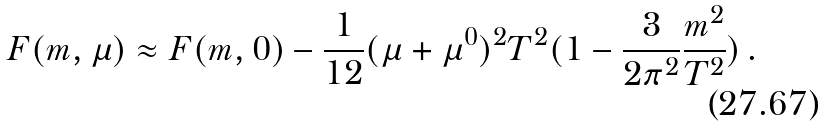<formula> <loc_0><loc_0><loc_500><loc_500>F ( m , \mu ) \approx F ( m , 0 ) - \frac { 1 } { 1 2 } ( \mu + \mu ^ { 0 } ) ^ { 2 } T ^ { 2 } ( 1 - \frac { 3 } { 2 \pi ^ { 2 } } \frac { m ^ { 2 } } { T ^ { 2 } } ) \, .</formula> 